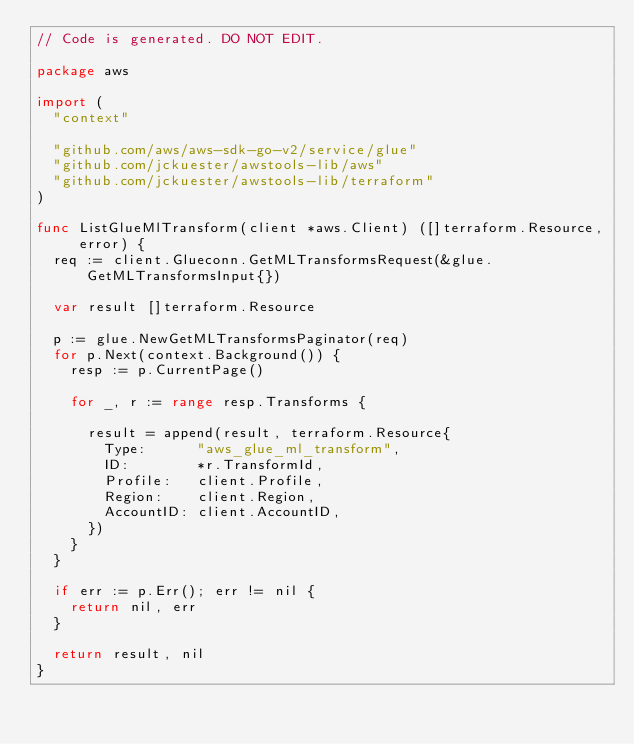Convert code to text. <code><loc_0><loc_0><loc_500><loc_500><_Go_>// Code is generated. DO NOT EDIT.

package aws

import (
	"context"

	"github.com/aws/aws-sdk-go-v2/service/glue"
	"github.com/jckuester/awstools-lib/aws"
	"github.com/jckuester/awstools-lib/terraform"
)

func ListGlueMlTransform(client *aws.Client) ([]terraform.Resource, error) {
	req := client.Glueconn.GetMLTransformsRequest(&glue.GetMLTransformsInput{})

	var result []terraform.Resource

	p := glue.NewGetMLTransformsPaginator(req)
	for p.Next(context.Background()) {
		resp := p.CurrentPage()

		for _, r := range resp.Transforms {

			result = append(result, terraform.Resource{
				Type:      "aws_glue_ml_transform",
				ID:        *r.TransformId,
				Profile:   client.Profile,
				Region:    client.Region,
				AccountID: client.AccountID,
			})
		}
	}

	if err := p.Err(); err != nil {
		return nil, err
	}

	return result, nil
}
</code> 